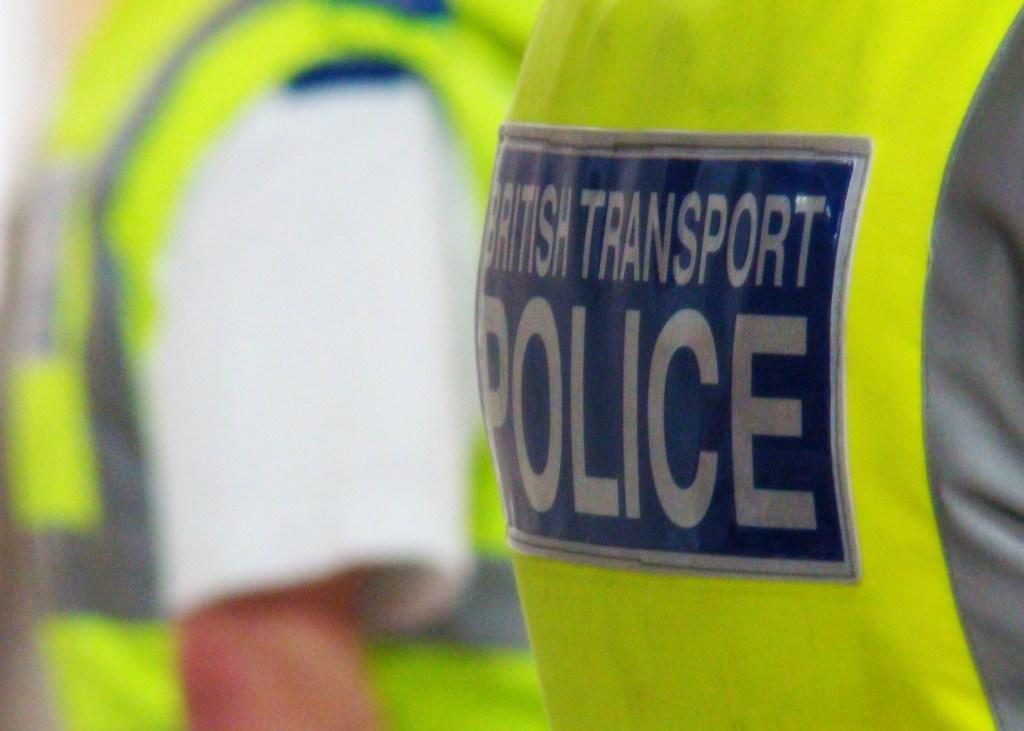<image>
Present a compact description of the photo's key features. A close up of the rear of a hig vis vest saying British Transport Police. 